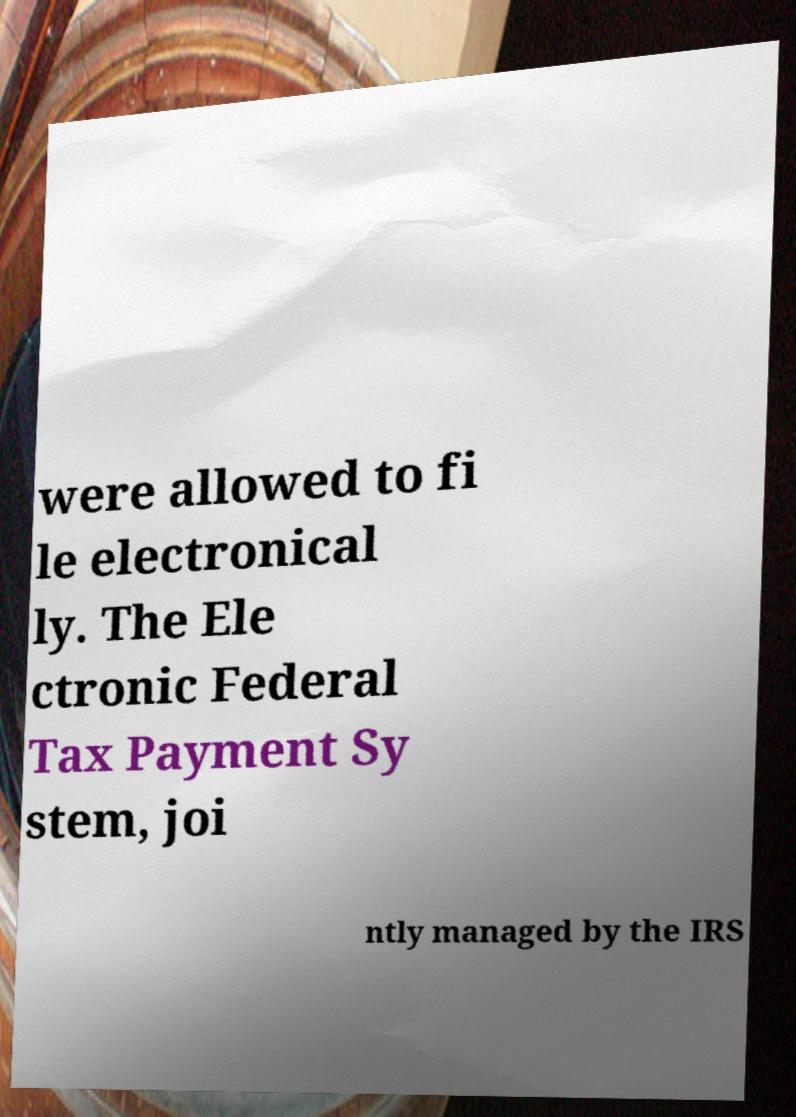Can you read and provide the text displayed in the image?This photo seems to have some interesting text. Can you extract and type it out for me? were allowed to fi le electronical ly. The Ele ctronic Federal Tax Payment Sy stem, joi ntly managed by the IRS 